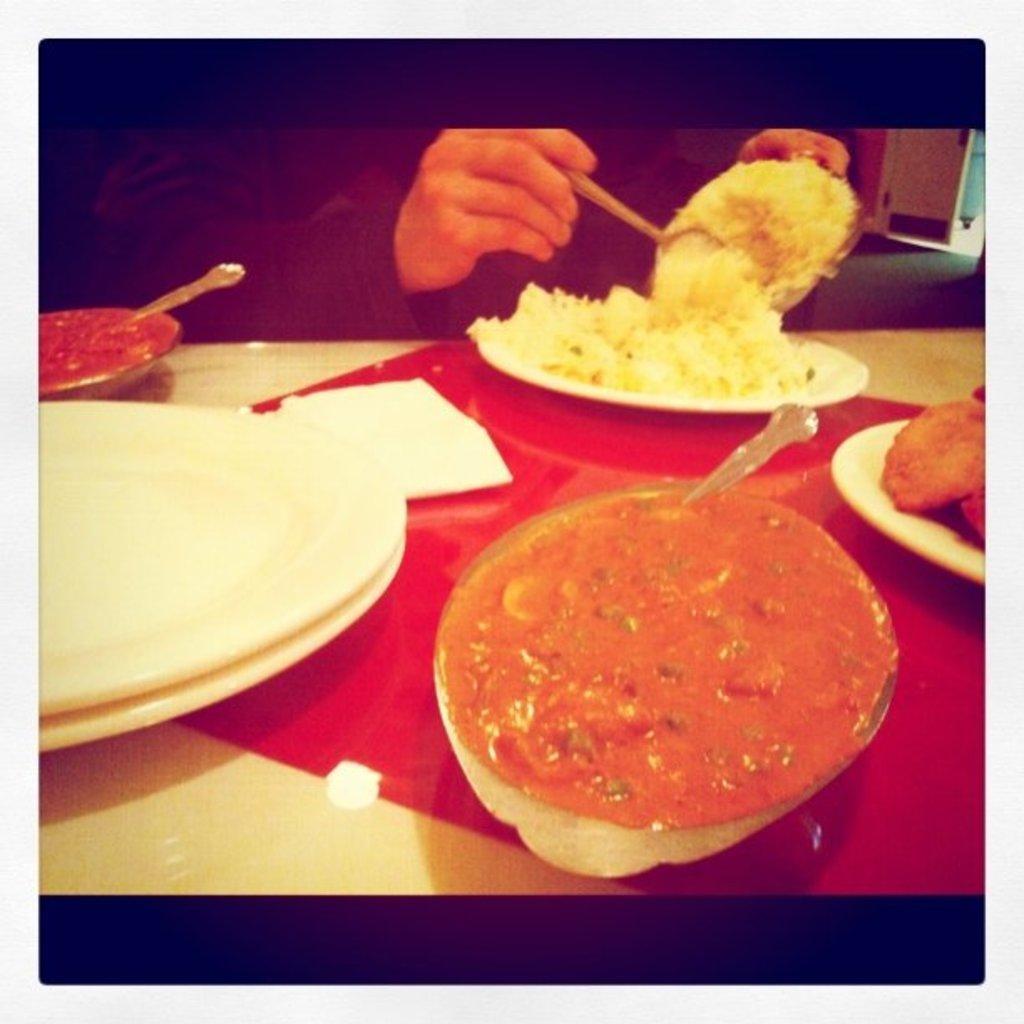In one or two sentences, can you explain what this image depicts? This is an edited image with the black borders and this picture is clicked inside. In the foreground there is a table on the top of which many number of food items are placed and there is a person seems to be sitting on the chair and putting some food in the plate placed on the top of the table. In the background we can see the ground and some other items.. 